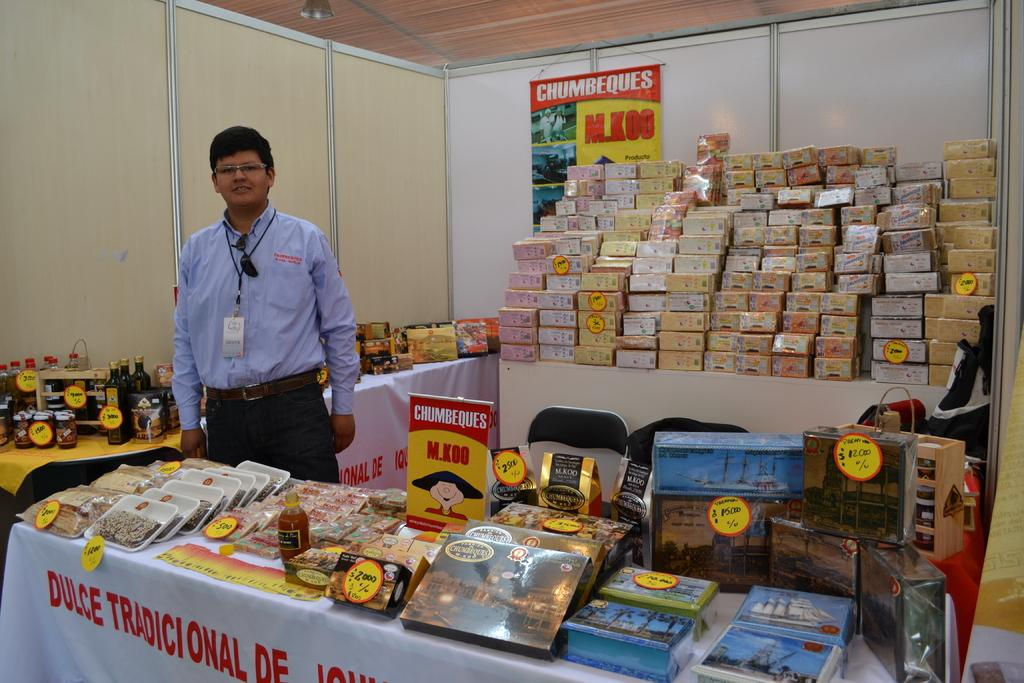<image>
Give a short and clear explanation of the subsequent image. the word dulce is on the table under the man 